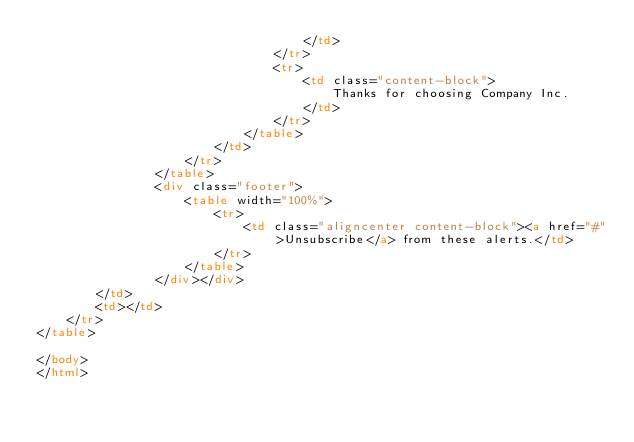<code> <loc_0><loc_0><loc_500><loc_500><_HTML_>                                    </td>
                                </tr>
                                <tr>
                                    <td class="content-block">
                                        Thanks for choosing Company Inc.
                                    </td>
                                </tr>
                            </table>
                        </td>
                    </tr>
                </table>
                <div class="footer">
                    <table width="100%">
                        <tr>
                            <td class="aligncenter content-block"><a href="#">Unsubscribe</a> from these alerts.</td>
                        </tr>
                    </table>
                </div></div>
        </td>
        <td></td>
    </tr>
</table>

</body>
</html>
</code> 